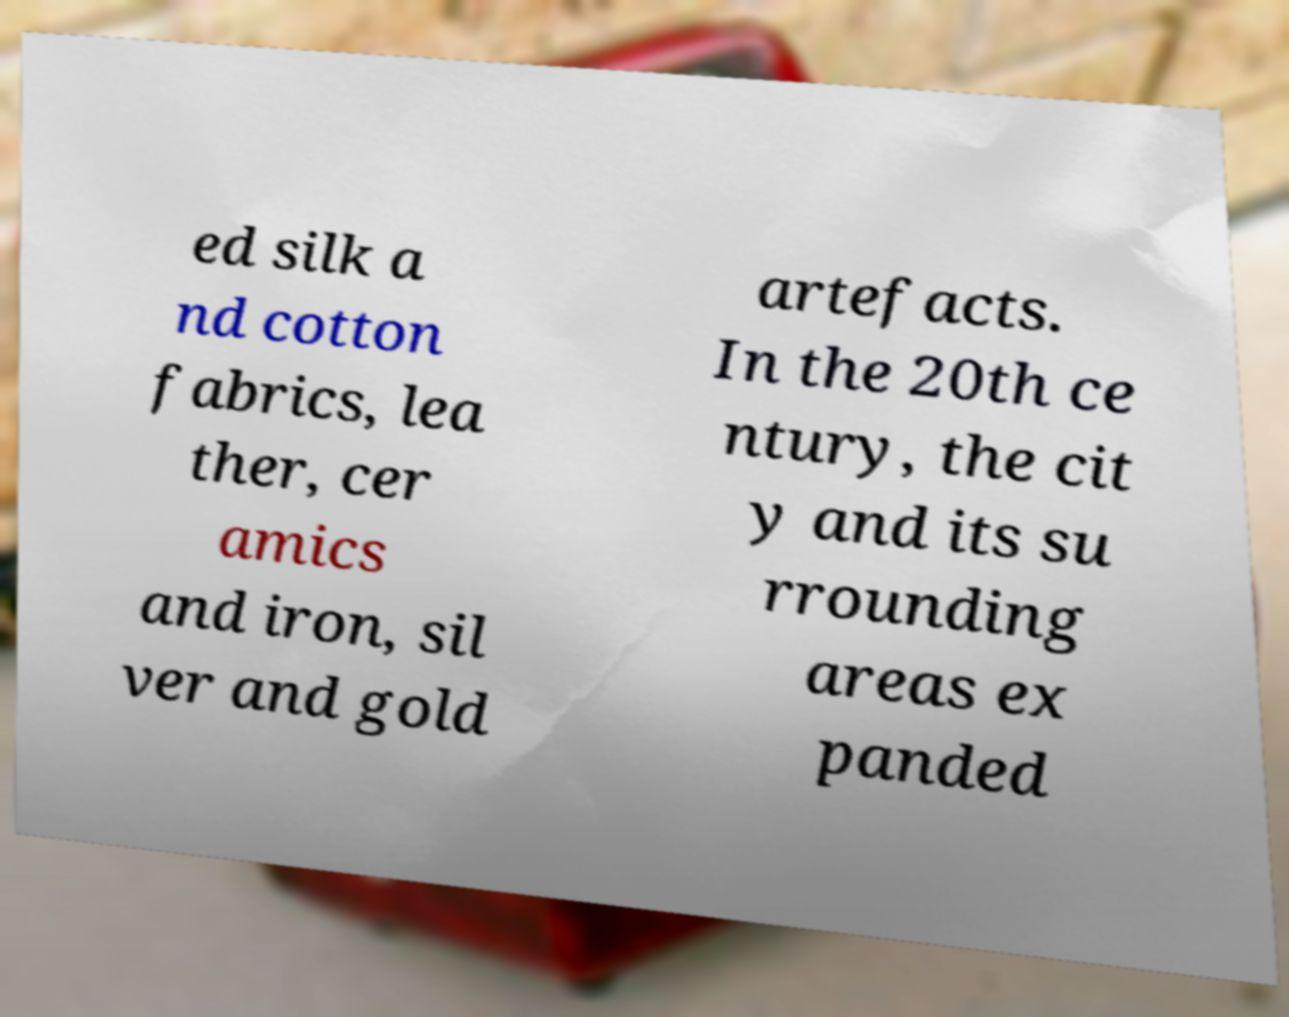Please identify and transcribe the text found in this image. ed silk a nd cotton fabrics, lea ther, cer amics and iron, sil ver and gold artefacts. In the 20th ce ntury, the cit y and its su rrounding areas ex panded 